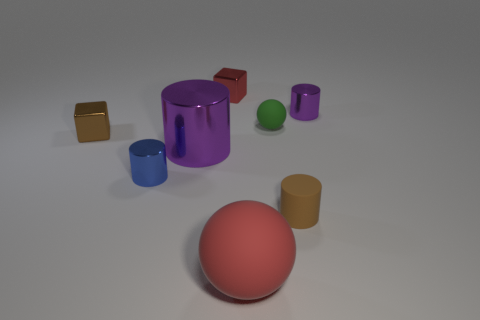There is a block that is the same color as the large ball; what is its size?
Offer a very short reply. Small. How many cylinders are big purple objects or small brown objects?
Keep it short and to the point. 2. Is the number of large red rubber objects left of the red ball greater than the number of metallic things that are in front of the brown matte cylinder?
Keep it short and to the point. No. How many small shiny cylinders have the same color as the big cylinder?
Give a very brief answer. 1. The brown thing that is the same material as the large red thing is what size?
Provide a succinct answer. Small. What number of objects are balls right of the big red matte sphere or tiny blue shiny cylinders?
Make the answer very short. 2. There is a matte ball in front of the tiny brown rubber thing; is its color the same as the small rubber ball?
Give a very brief answer. No. The brown shiny thing that is the same shape as the tiny red metallic object is what size?
Give a very brief answer. Small. There is a block that is behind the brown object that is left of the block behind the small ball; what is its color?
Your response must be concise. Red. Do the green object and the small purple object have the same material?
Keep it short and to the point. No. 